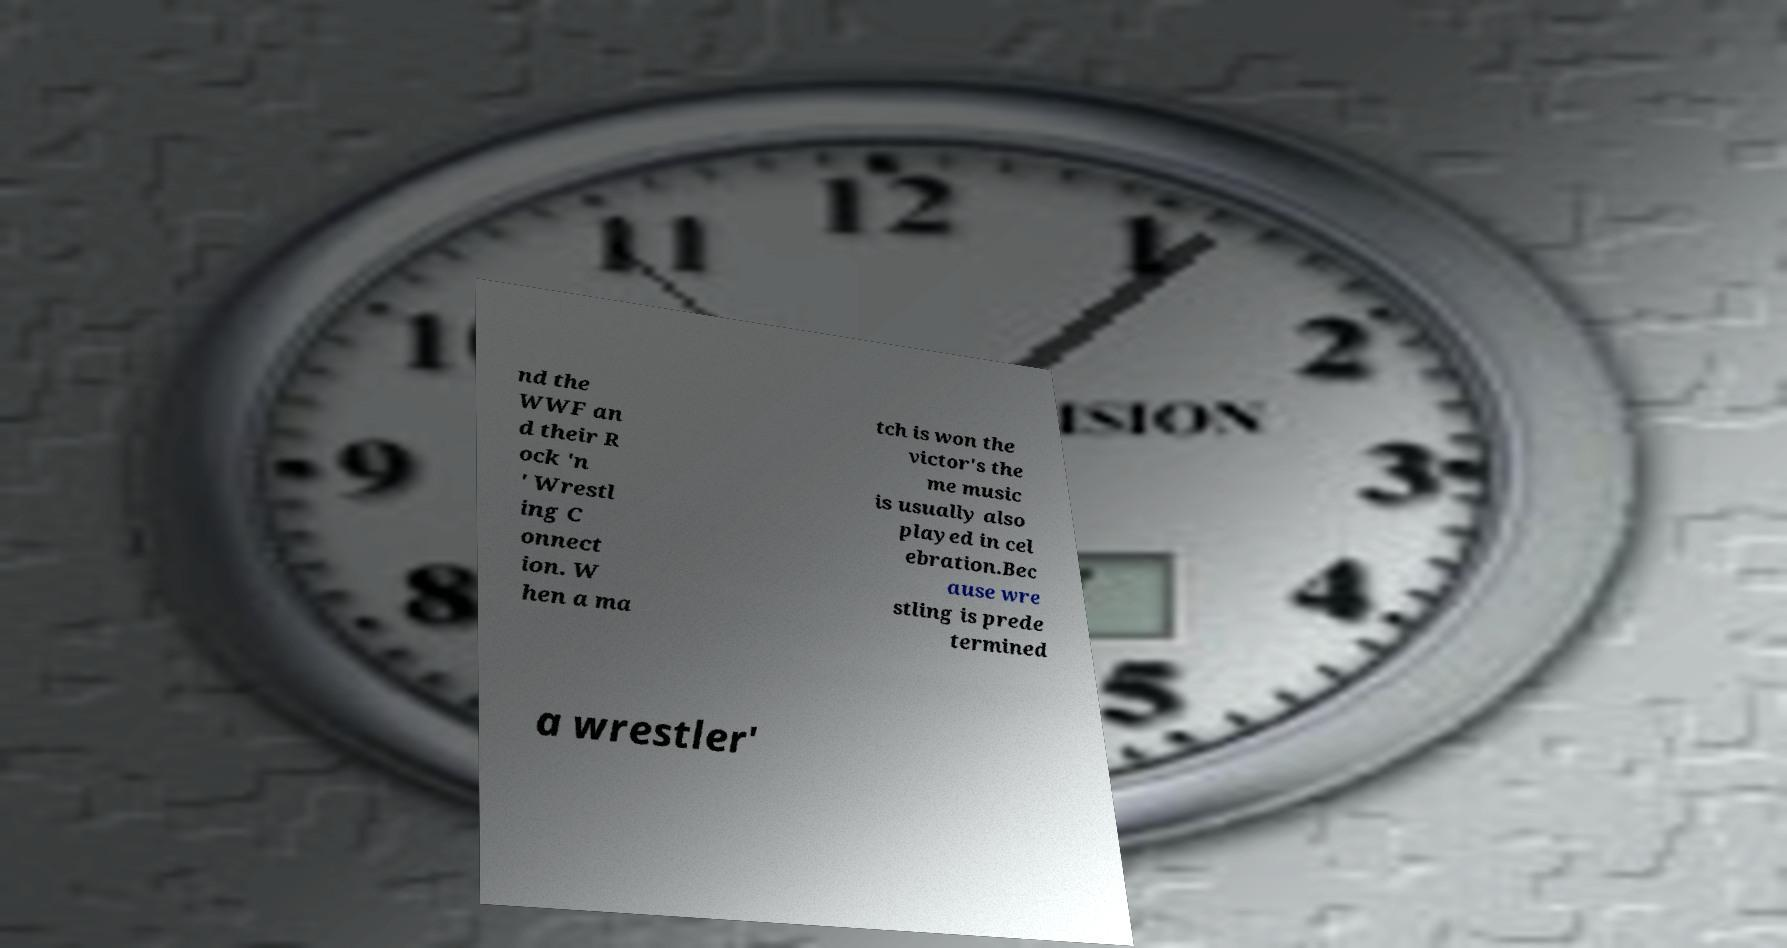Can you accurately transcribe the text from the provided image for me? nd the WWF an d their R ock 'n ' Wrestl ing C onnect ion. W hen a ma tch is won the victor's the me music is usually also played in cel ebration.Bec ause wre stling is prede termined a wrestler' 